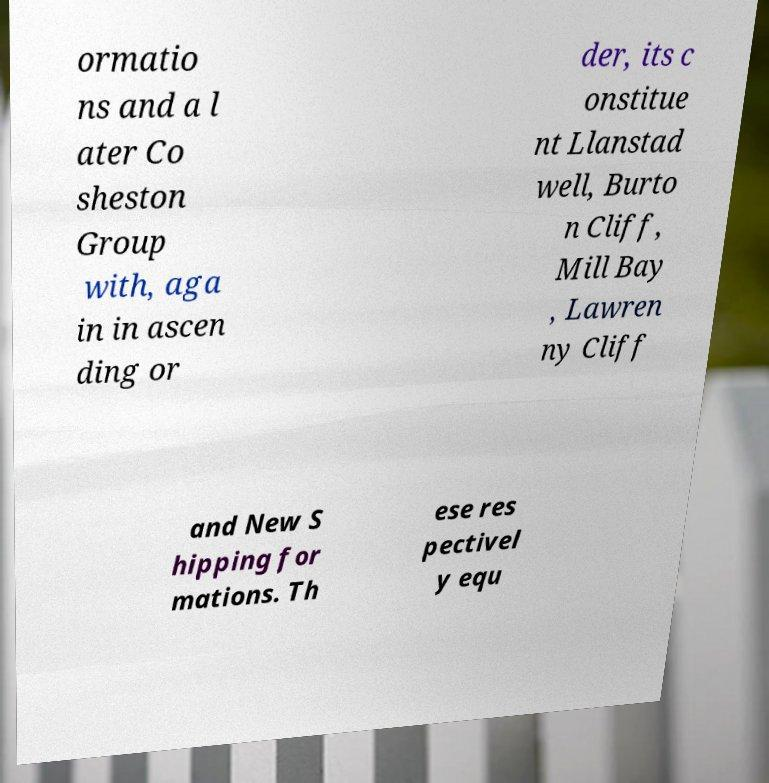Can you accurately transcribe the text from the provided image for me? ormatio ns and a l ater Co sheston Group with, aga in in ascen ding or der, its c onstitue nt Llanstad well, Burto n Cliff, Mill Bay , Lawren ny Cliff and New S hipping for mations. Th ese res pectivel y equ 